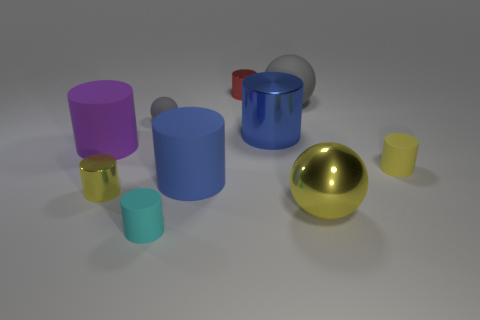What material is the thing that is the same color as the large matte ball?
Your response must be concise. Rubber. There is a tiny matte cylinder that is behind the cyan thing; is its color the same as the big metallic sphere that is in front of the purple cylinder?
Your answer should be compact. Yes. Is there a big gray cylinder?
Offer a terse response. No. How many other objects are the same color as the large matte ball?
Offer a very short reply. 1. Is the number of small gray metal objects less than the number of small red cylinders?
Provide a succinct answer. Yes. The large shiny object on the left side of the yellow metal object on the right side of the big matte sphere is what shape?
Give a very brief answer. Cylinder. Are there any gray spheres behind the purple object?
Ensure brevity in your answer.  Yes. What is the color of the rubber ball that is the same size as the purple rubber thing?
Your answer should be very brief. Gray. What number of yellow things have the same material as the purple cylinder?
Your answer should be compact. 1. How many other objects are there of the same size as the cyan matte cylinder?
Your response must be concise. 4. 